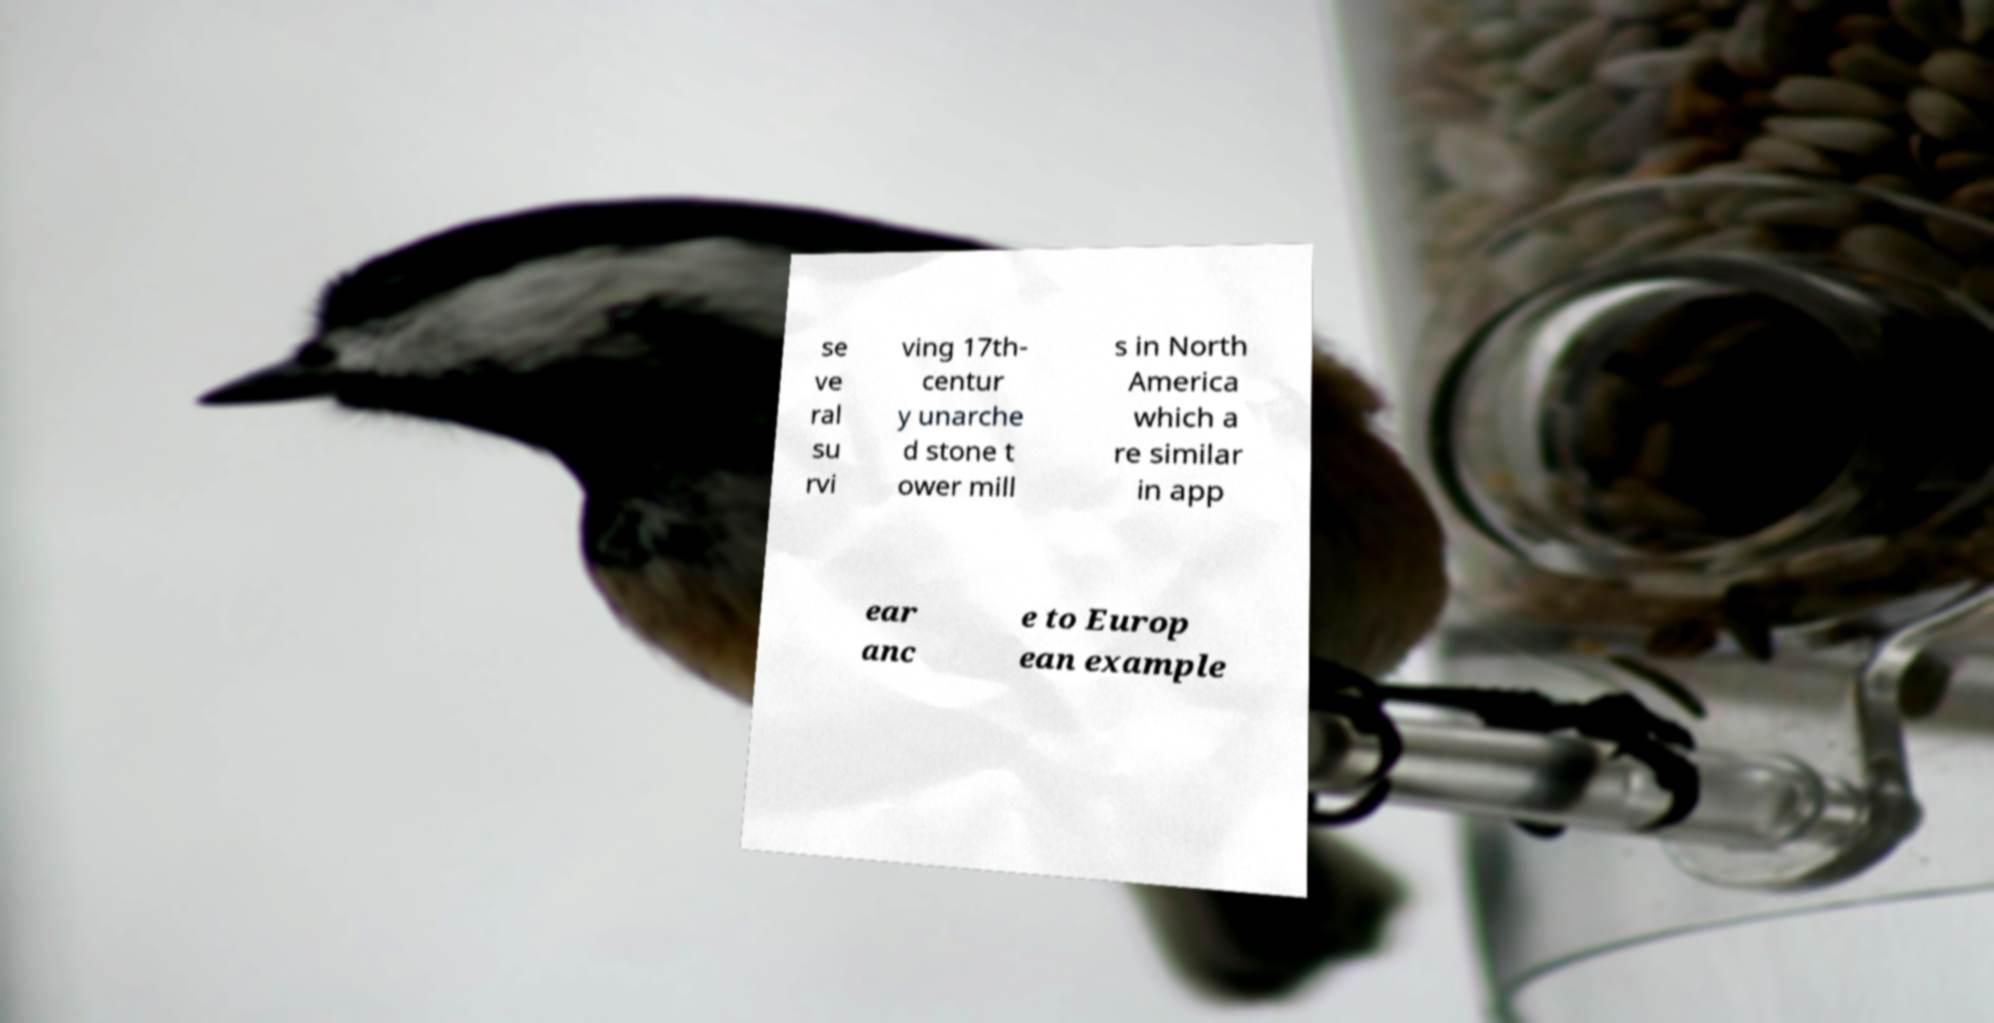Could you extract and type out the text from this image? se ve ral su rvi ving 17th- centur y unarche d stone t ower mill s in North America which a re similar in app ear anc e to Europ ean example 